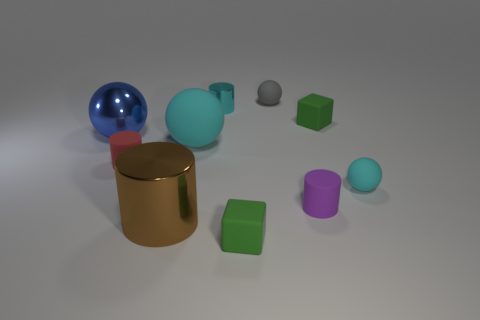Subtract all large blue metallic spheres. How many spheres are left? 3 Subtract 2 cylinders. How many cylinders are left? 2 Subtract all yellow spheres. How many purple cylinders are left? 1 Subtract all purple cylinders. How many cylinders are left? 3 Subtract 1 red cylinders. How many objects are left? 9 Subtract all blocks. How many objects are left? 8 Subtract all blue blocks. Subtract all yellow cylinders. How many blocks are left? 2 Subtract all green rubber blocks. Subtract all shiny balls. How many objects are left? 7 Add 3 brown metal objects. How many brown metal objects are left? 4 Add 8 red objects. How many red objects exist? 9 